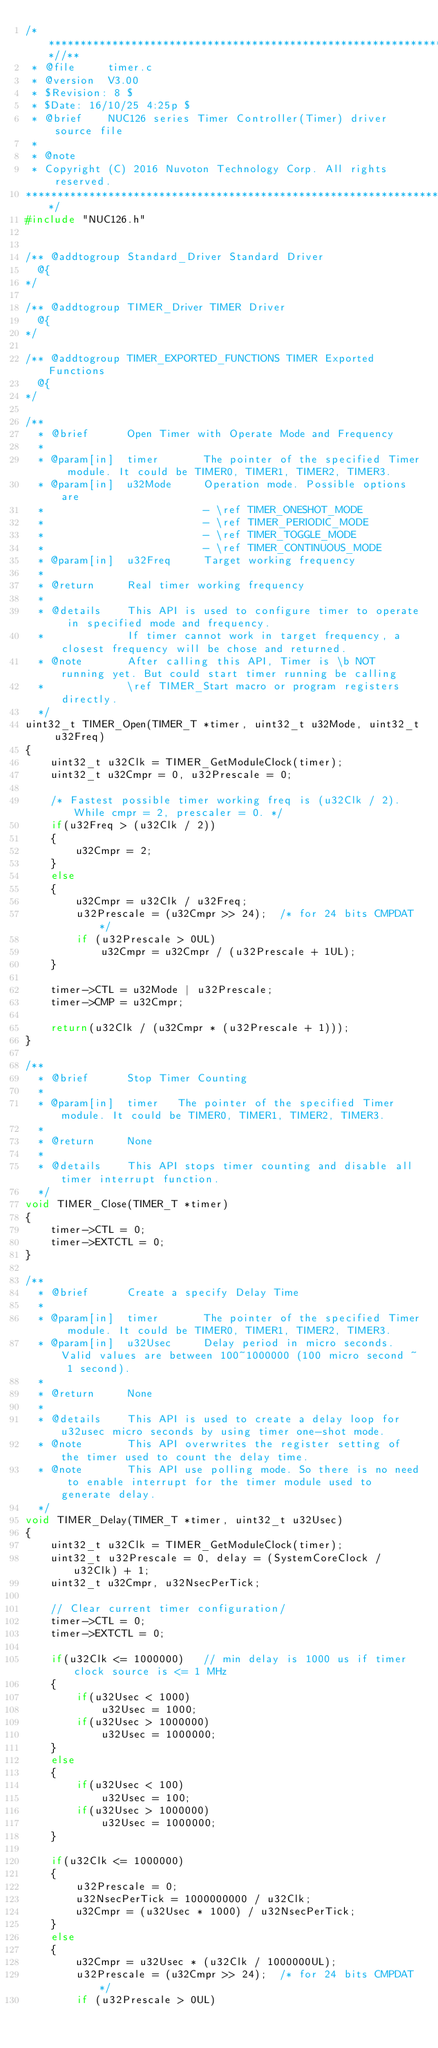Convert code to text. <code><loc_0><loc_0><loc_500><loc_500><_C_>/**************************************************************************//**
 * @file     timer.c
 * @version  V3.00
 * $Revision: 8 $
 * $Date: 16/10/25 4:25p $
 * @brief    NUC126 series Timer Controller(Timer) driver source file
 *
 * @note
 * Copyright (C) 2016 Nuvoton Technology Corp. All rights reserved.
*****************************************************************************/
#include "NUC126.h"


/** @addtogroup Standard_Driver Standard Driver
  @{
*/

/** @addtogroup TIMER_Driver TIMER Driver
  @{
*/

/** @addtogroup TIMER_EXPORTED_FUNCTIONS TIMER Exported Functions
  @{
*/

/**
  * @brief      Open Timer with Operate Mode and Frequency
  *
  * @param[in]  timer       The pointer of the specified Timer module. It could be TIMER0, TIMER1, TIMER2, TIMER3.
  * @param[in]  u32Mode     Operation mode. Possible options are
  *                         - \ref TIMER_ONESHOT_MODE
  *                         - \ref TIMER_PERIODIC_MODE
  *                         - \ref TIMER_TOGGLE_MODE
  *                         - \ref TIMER_CONTINUOUS_MODE
  * @param[in]  u32Freq     Target working frequency
  *
  * @return     Real timer working frequency
  *
  * @details    This API is used to configure timer to operate in specified mode and frequency.
  *             If timer cannot work in target frequency, a closest frequency will be chose and returned.
  * @note       After calling this API, Timer is \b NOT running yet. But could start timer running be calling
  *             \ref TIMER_Start macro or program registers directly.
  */
uint32_t TIMER_Open(TIMER_T *timer, uint32_t u32Mode, uint32_t u32Freq)
{
    uint32_t u32Clk = TIMER_GetModuleClock(timer);
    uint32_t u32Cmpr = 0, u32Prescale = 0;

    /* Fastest possible timer working freq is (u32Clk / 2). While cmpr = 2, prescaler = 0. */
    if(u32Freq > (u32Clk / 2))
    {
        u32Cmpr = 2;
    }
    else
    {
        u32Cmpr = u32Clk / u32Freq;
        u32Prescale = (u32Cmpr >> 24);  /* for 24 bits CMPDAT */
        if (u32Prescale > 0UL)
            u32Cmpr = u32Cmpr / (u32Prescale + 1UL);
    }

    timer->CTL = u32Mode | u32Prescale;
    timer->CMP = u32Cmpr;

    return(u32Clk / (u32Cmpr * (u32Prescale + 1)));
}

/**
  * @brief      Stop Timer Counting
  *
  * @param[in]  timer   The pointer of the specified Timer module. It could be TIMER0, TIMER1, TIMER2, TIMER3.
  *
  * @return     None
  *
  * @details    This API stops timer counting and disable all timer interrupt function.
  */
void TIMER_Close(TIMER_T *timer)
{
    timer->CTL = 0;
    timer->EXTCTL = 0;
}

/**
  * @brief      Create a specify Delay Time
  *
  * @param[in]  timer       The pointer of the specified Timer module. It could be TIMER0, TIMER1, TIMER2, TIMER3.
  * @param[in]  u32Usec     Delay period in micro seconds. Valid values are between 100~1000000 (100 micro second ~ 1 second).
  *
  * @return     None
  *
  * @details    This API is used to create a delay loop for u32usec micro seconds by using timer one-shot mode.
  * @note       This API overwrites the register setting of the timer used to count the delay time.
  * @note       This API use polling mode. So there is no need to enable interrupt for the timer module used to generate delay.
  */
void TIMER_Delay(TIMER_T *timer, uint32_t u32Usec)
{
    uint32_t u32Clk = TIMER_GetModuleClock(timer);
    uint32_t u32Prescale = 0, delay = (SystemCoreClock / u32Clk) + 1;
    uint32_t u32Cmpr, u32NsecPerTick;

    // Clear current timer configuration/
    timer->CTL = 0;
    timer->EXTCTL = 0;

    if(u32Clk <= 1000000)   // min delay is 1000 us if timer clock source is <= 1 MHz
    {
        if(u32Usec < 1000)
            u32Usec = 1000;
        if(u32Usec > 1000000)
            u32Usec = 1000000;
    }
    else
    {
        if(u32Usec < 100)
            u32Usec = 100;
        if(u32Usec > 1000000)
            u32Usec = 1000000;
    }

    if(u32Clk <= 1000000)
    {
        u32Prescale = 0;
        u32NsecPerTick = 1000000000 / u32Clk;
        u32Cmpr = (u32Usec * 1000) / u32NsecPerTick;
    }
    else
    {
        u32Cmpr = u32Usec * (u32Clk / 1000000UL);
        u32Prescale = (u32Cmpr >> 24);  /* for 24 bits CMPDAT */
        if (u32Prescale > 0UL)</code> 